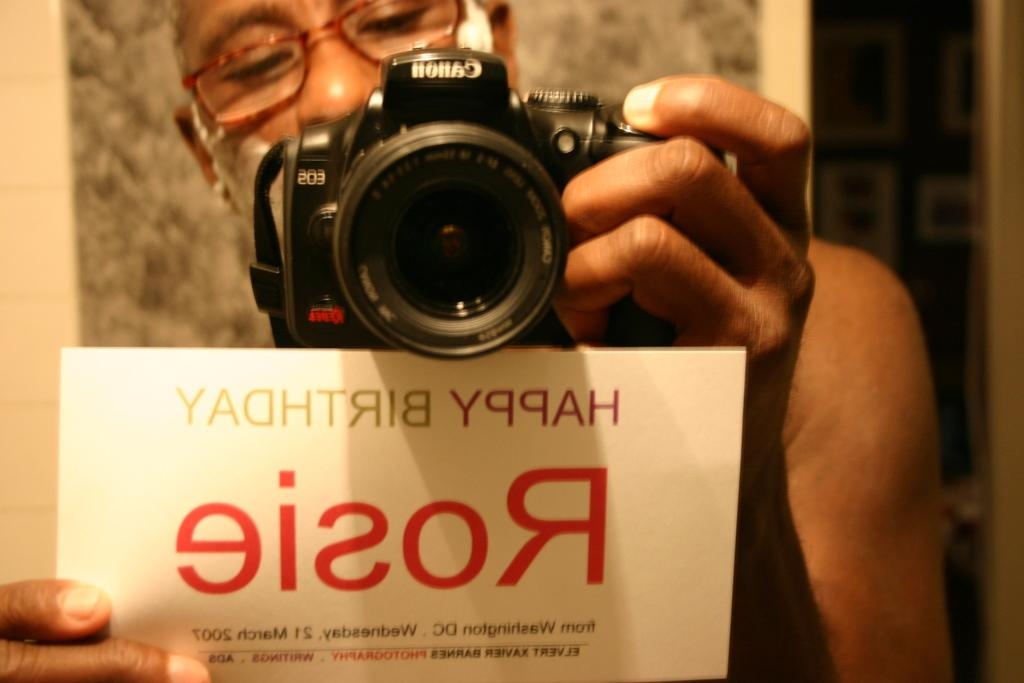What is the main subject of the image? There is a person in the image. What is the person holding in one hand? The person is holding a camera in one hand. What is the person holding in the other hand? The person is holding a paper with text in the other hand. Can you describe the background of the image? The background of the image is blurred. What type of pie is being served on the chair in the image? There is no pie or chair present in the image. 